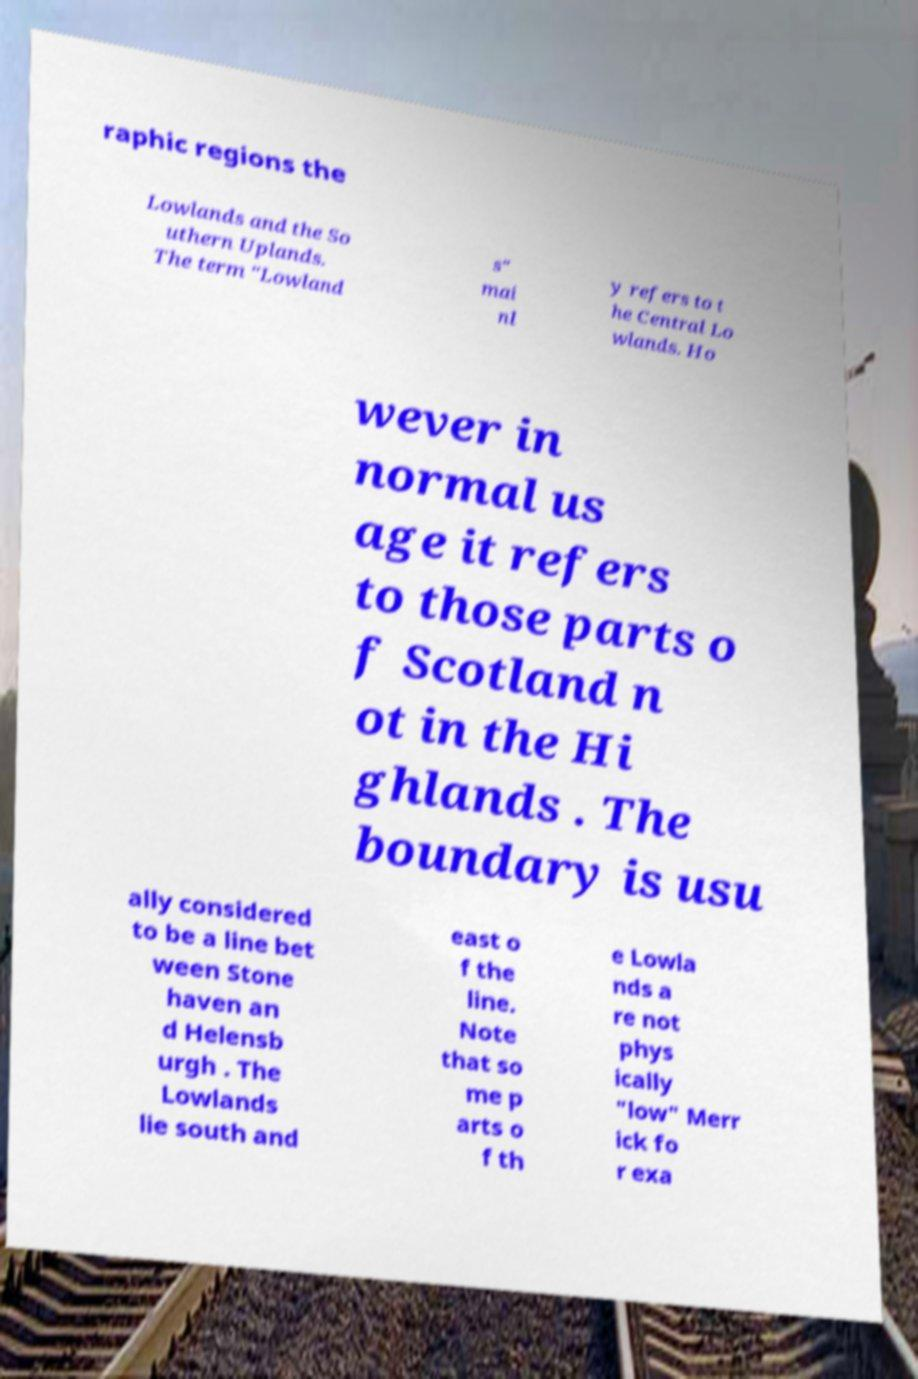There's text embedded in this image that I need extracted. Can you transcribe it verbatim? raphic regions the Lowlands and the So uthern Uplands. The term "Lowland s" mai nl y refers to t he Central Lo wlands. Ho wever in normal us age it refers to those parts o f Scotland n ot in the Hi ghlands . The boundary is usu ally considered to be a line bet ween Stone haven an d Helensb urgh . The Lowlands lie south and east o f the line. Note that so me p arts o f th e Lowla nds a re not phys ically "low" Merr ick fo r exa 